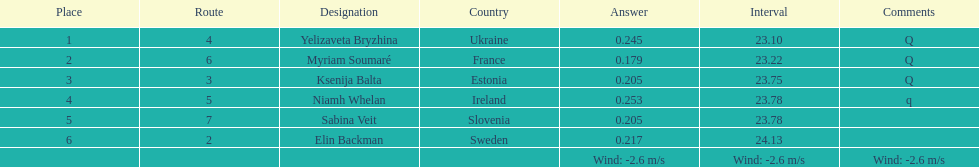Whose time is more than. 24.00? Elin Backman. 